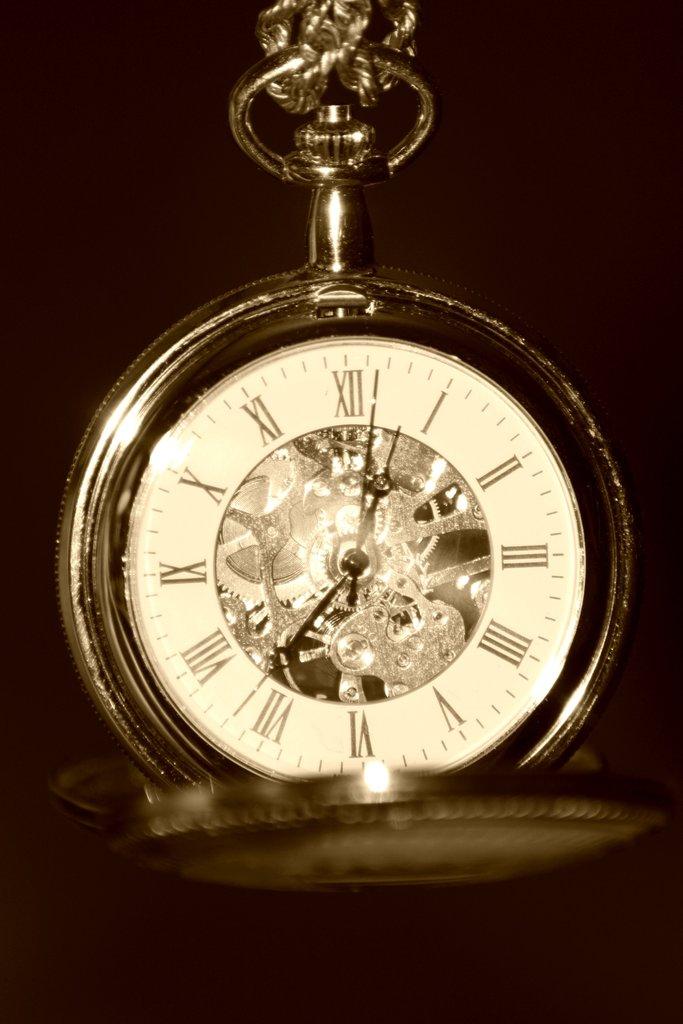What is the time listed?
Give a very brief answer. 7:02. 